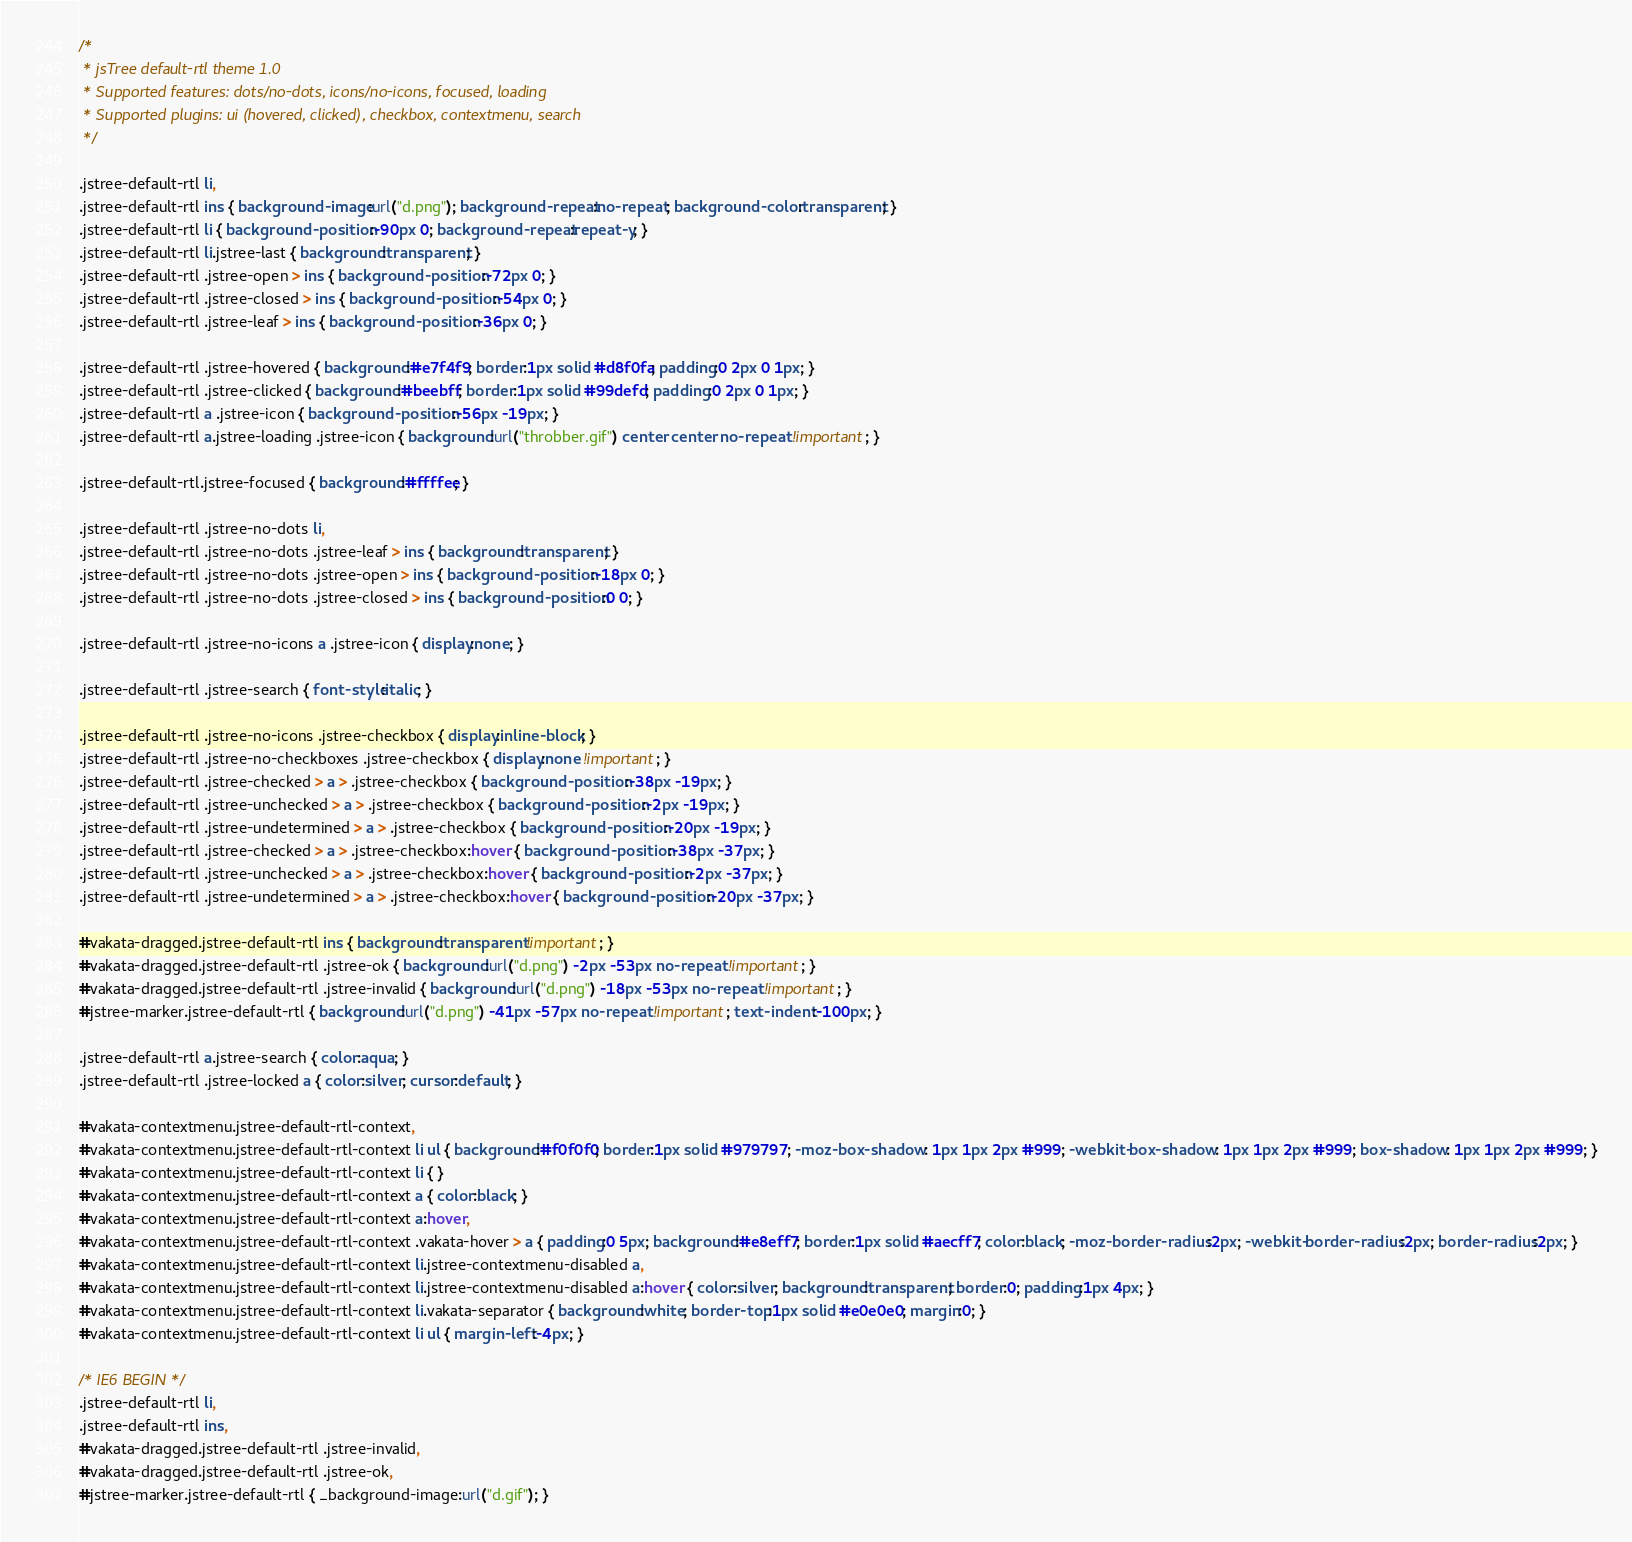<code> <loc_0><loc_0><loc_500><loc_500><_CSS_>/*
 * jsTree default-rtl theme 1.0
 * Supported features: dots/no-dots, icons/no-icons, focused, loading
 * Supported plugins: ui (hovered, clicked), checkbox, contextmenu, search
 */

.jstree-default-rtl li, 
.jstree-default-rtl ins { background-image:url("d.png"); background-repeat:no-repeat; background-color:transparent; }
.jstree-default-rtl li { background-position:-90px 0; background-repeat:repeat-y; }
.jstree-default-rtl li.jstree-last { background:transparent; }
.jstree-default-rtl .jstree-open > ins { background-position:-72px 0; }
.jstree-default-rtl .jstree-closed > ins { background-position:-54px 0; }
.jstree-default-rtl .jstree-leaf > ins { background-position:-36px 0; }

.jstree-default-rtl .jstree-hovered { background:#e7f4f9; border:1px solid #d8f0fa; padding:0 2px 0 1px; }
.jstree-default-rtl .jstree-clicked { background:#beebff; border:1px solid #99defd; padding:0 2px 0 1px; }
.jstree-default-rtl a .jstree-icon { background-position:-56px -19px; }
.jstree-default-rtl a.jstree-loading .jstree-icon { background:url("throbber.gif") center center no-repeat !important; }

.jstree-default-rtl.jstree-focused { background:#ffffee; }

.jstree-default-rtl .jstree-no-dots li, 
.jstree-default-rtl .jstree-no-dots .jstree-leaf > ins { background:transparent; }
.jstree-default-rtl .jstree-no-dots .jstree-open > ins { background-position:-18px 0; }
.jstree-default-rtl .jstree-no-dots .jstree-closed > ins { background-position:0 0; }

.jstree-default-rtl .jstree-no-icons a .jstree-icon { display:none; }

.jstree-default-rtl .jstree-search { font-style:italic; }

.jstree-default-rtl .jstree-no-icons .jstree-checkbox { display:inline-block; }
.jstree-default-rtl .jstree-no-checkboxes .jstree-checkbox { display:none !important; }
.jstree-default-rtl .jstree-checked > a > .jstree-checkbox { background-position:-38px -19px; }
.jstree-default-rtl .jstree-unchecked > a > .jstree-checkbox { background-position:-2px -19px; }
.jstree-default-rtl .jstree-undetermined > a > .jstree-checkbox { background-position:-20px -19px; }
.jstree-default-rtl .jstree-checked > a > .jstree-checkbox:hover { background-position:-38px -37px; }
.jstree-default-rtl .jstree-unchecked > a > .jstree-checkbox:hover { background-position:-2px -37px; }
.jstree-default-rtl .jstree-undetermined > a > .jstree-checkbox:hover { background-position:-20px -37px; }

#vakata-dragged.jstree-default-rtl ins { background:transparent !important; }
#vakata-dragged.jstree-default-rtl .jstree-ok { background:url("d.png") -2px -53px no-repeat !important; }
#vakata-dragged.jstree-default-rtl .jstree-invalid { background:url("d.png") -18px -53px no-repeat !important; }
#jstree-marker.jstree-default-rtl { background:url("d.png") -41px -57px no-repeat !important; text-indent:-100px; }

.jstree-default-rtl a.jstree-search { color:aqua; }
.jstree-default-rtl .jstree-locked a { color:silver; cursor:default; }

#vakata-contextmenu.jstree-default-rtl-context, 
#vakata-contextmenu.jstree-default-rtl-context li ul { background:#f0f0f0; border:1px solid #979797; -moz-box-shadow: 1px 1px 2px #999; -webkit-box-shadow: 1px 1px 2px #999; box-shadow: 1px 1px 2px #999; }
#vakata-contextmenu.jstree-default-rtl-context li { }
#vakata-contextmenu.jstree-default-rtl-context a { color:black; }
#vakata-contextmenu.jstree-default-rtl-context a:hover, 
#vakata-contextmenu.jstree-default-rtl-context .vakata-hover > a { padding:0 5px; background:#e8eff7; border:1px solid #aecff7; color:black; -moz-border-radius:2px; -webkit-border-radius:2px; border-radius:2px; }
#vakata-contextmenu.jstree-default-rtl-context li.jstree-contextmenu-disabled a, 
#vakata-contextmenu.jstree-default-rtl-context li.jstree-contextmenu-disabled a:hover { color:silver; background:transparent; border:0; padding:1px 4px; }
#vakata-contextmenu.jstree-default-rtl-context li.vakata-separator { background:white; border-top:1px solid #e0e0e0; margin:0; }
#vakata-contextmenu.jstree-default-rtl-context li ul { margin-left:-4px; }

/* IE6 BEGIN */
.jstree-default-rtl li, 
.jstree-default-rtl ins,
#vakata-dragged.jstree-default-rtl .jstree-invalid, 
#vakata-dragged.jstree-default-rtl .jstree-ok, 
#jstree-marker.jstree-default-rtl { _background-image:url("d.gif"); }</code> 